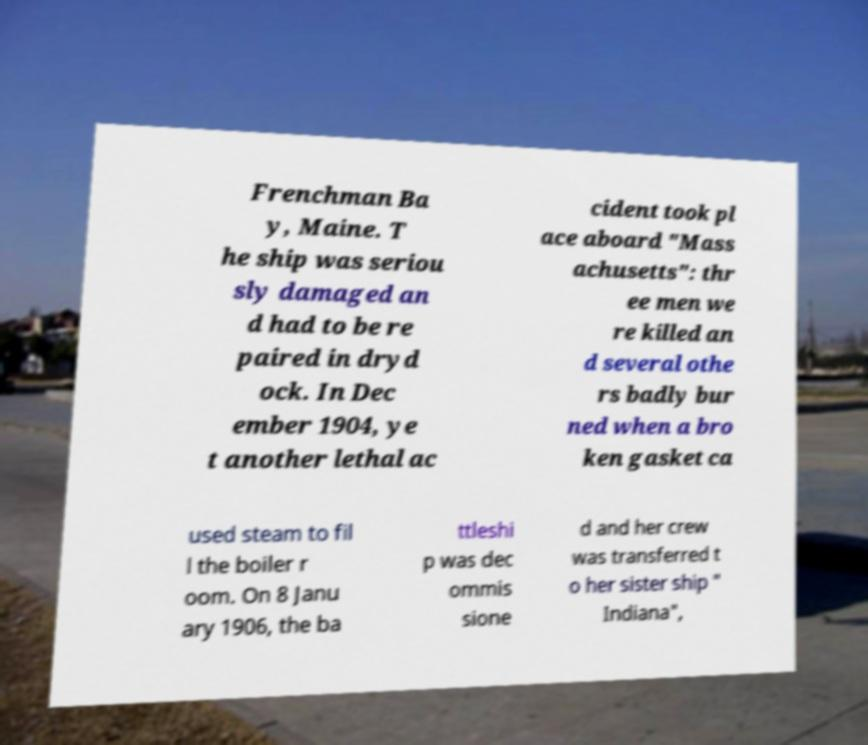I need the written content from this picture converted into text. Can you do that? Frenchman Ba y, Maine. T he ship was seriou sly damaged an d had to be re paired in dryd ock. In Dec ember 1904, ye t another lethal ac cident took pl ace aboard "Mass achusetts": thr ee men we re killed an d several othe rs badly bur ned when a bro ken gasket ca used steam to fil l the boiler r oom. On 8 Janu ary 1906, the ba ttleshi p was dec ommis sione d and her crew was transferred t o her sister ship " Indiana", 